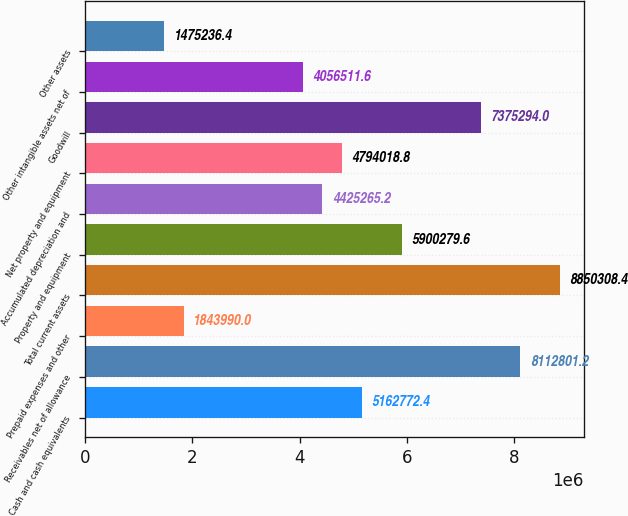<chart> <loc_0><loc_0><loc_500><loc_500><bar_chart><fcel>Cash and cash equivalents<fcel>Receivables net of allowance<fcel>Prepaid expenses and other<fcel>Total current assets<fcel>Property and equipment<fcel>Accumulated depreciation and<fcel>Net property and equipment<fcel>Goodwill<fcel>Other intangible assets net of<fcel>Other assets<nl><fcel>5.16277e+06<fcel>8.1128e+06<fcel>1.84399e+06<fcel>8.85031e+06<fcel>5.90028e+06<fcel>4.42527e+06<fcel>4.79402e+06<fcel>7.37529e+06<fcel>4.05651e+06<fcel>1.47524e+06<nl></chart> 